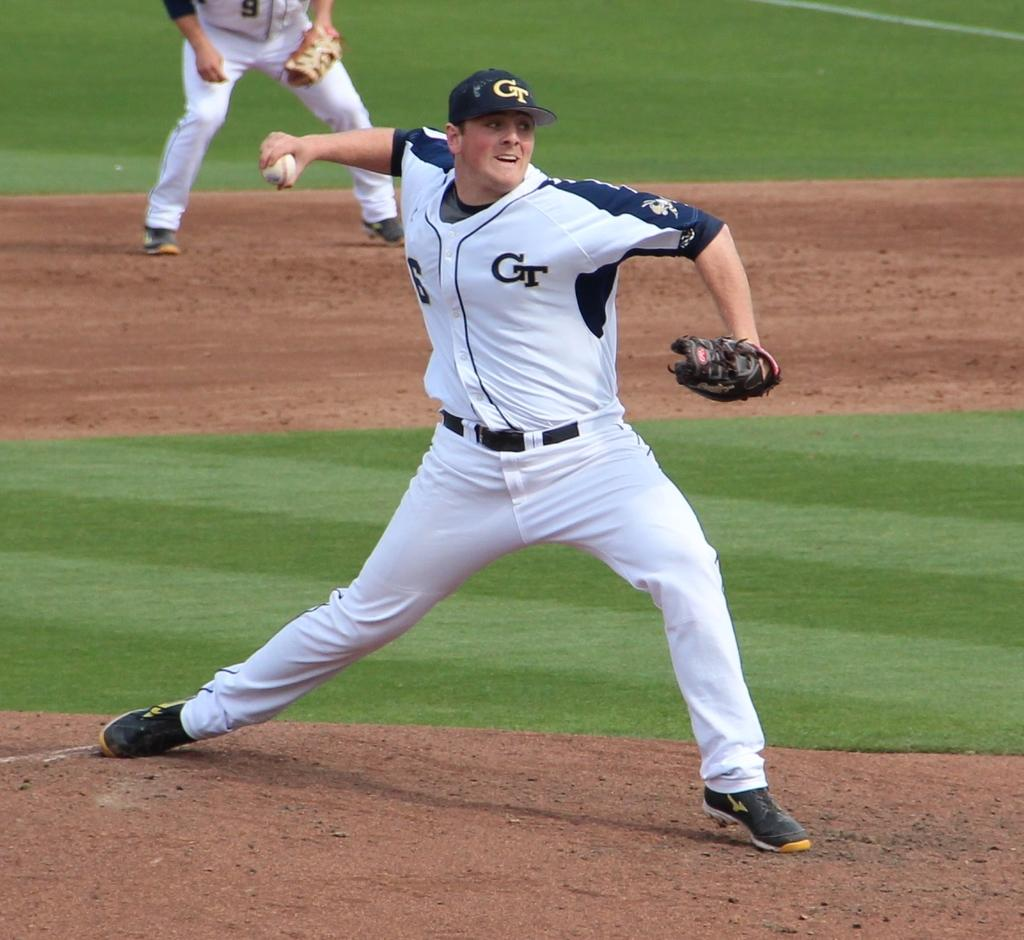How many people are present in the image? There are two persons standing in the image. What is one person holding in the image? One person is holding a ball. What type of surface is visible in the image? There is grass visible in the image. What type of iron is being used by the person in the image? There is no iron present in the image; it features two persons standing and one holding a ball. What subject is the person teaching in the image? There is no indication of teaching or any subject being taught in the image. 